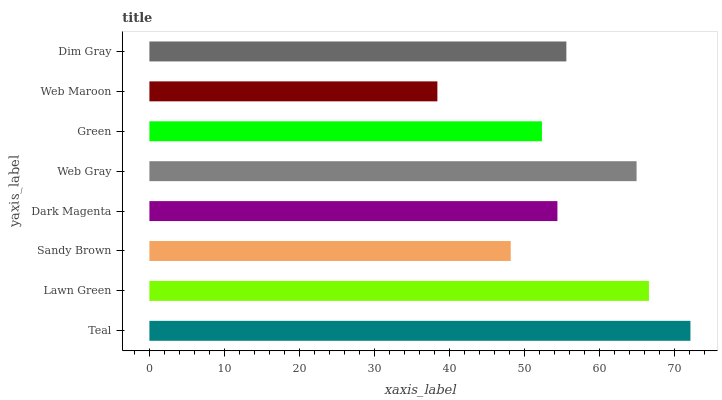Is Web Maroon the minimum?
Answer yes or no. Yes. Is Teal the maximum?
Answer yes or no. Yes. Is Lawn Green the minimum?
Answer yes or no. No. Is Lawn Green the maximum?
Answer yes or no. No. Is Teal greater than Lawn Green?
Answer yes or no. Yes. Is Lawn Green less than Teal?
Answer yes or no. Yes. Is Lawn Green greater than Teal?
Answer yes or no. No. Is Teal less than Lawn Green?
Answer yes or no. No. Is Dim Gray the high median?
Answer yes or no. Yes. Is Dark Magenta the low median?
Answer yes or no. Yes. Is Sandy Brown the high median?
Answer yes or no. No. Is Sandy Brown the low median?
Answer yes or no. No. 